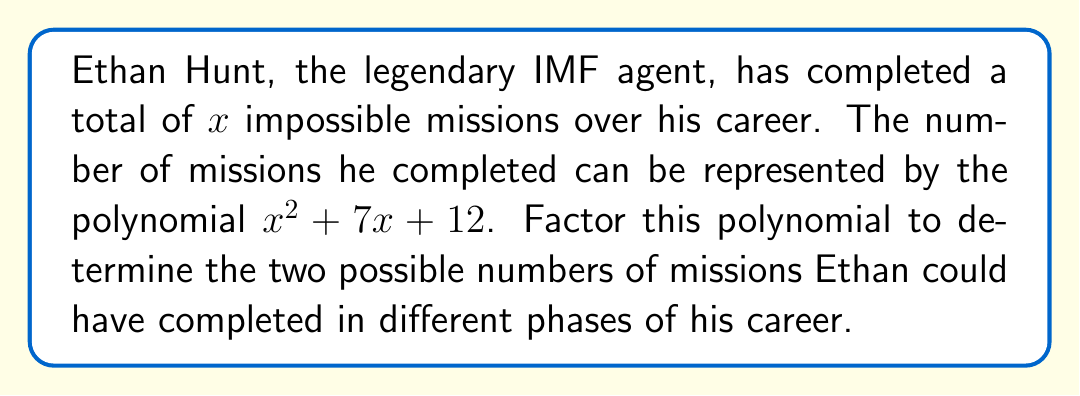Can you answer this question? To factor the polynomial $x^2 + 7x + 12$, we need to find two numbers that multiply to give 12 and add up to 7. Let's approach this step-by-step:

1) First, let's list the factor pairs of 12:
   1 and 12
   2 and 6
   3 and 4

2) Now, we need to check which pair adds up to 7:
   1 + 12 = 13
   2 + 6 = 8
   3 + 4 = 7

3) We found that 3 and 4 are the numbers we're looking for.

4) Now we can rewrite the middle term of our polynomial:
   $x^2 + 7x + 12 = x^2 + 3x + 4x + 12$

5) We can group these terms:
   $(x^2 + 3x) + (4x + 12)$

6) Factor out the common factors from each group:
   $x(x + 3) + 4(x + 3)$

7) We can now factor out $(x + 3)$:
   $(x + 3)(x + 4)$

Therefore, the factored form of $x^2 + 7x + 12$ is $(x + 3)(x + 4)$.

This means Ethan could have completed 3 missions in one phase of his career and 4 in another, totaling 7 missions, or he could have completed no missions in the early phase and 7 later in his career.
Answer: $(x + 3)(x + 4)$ 